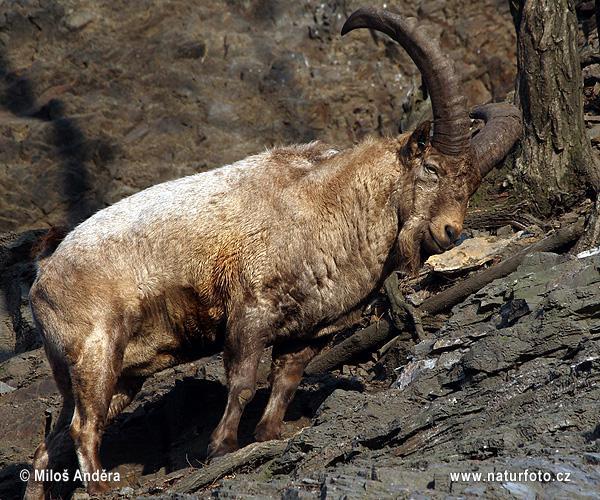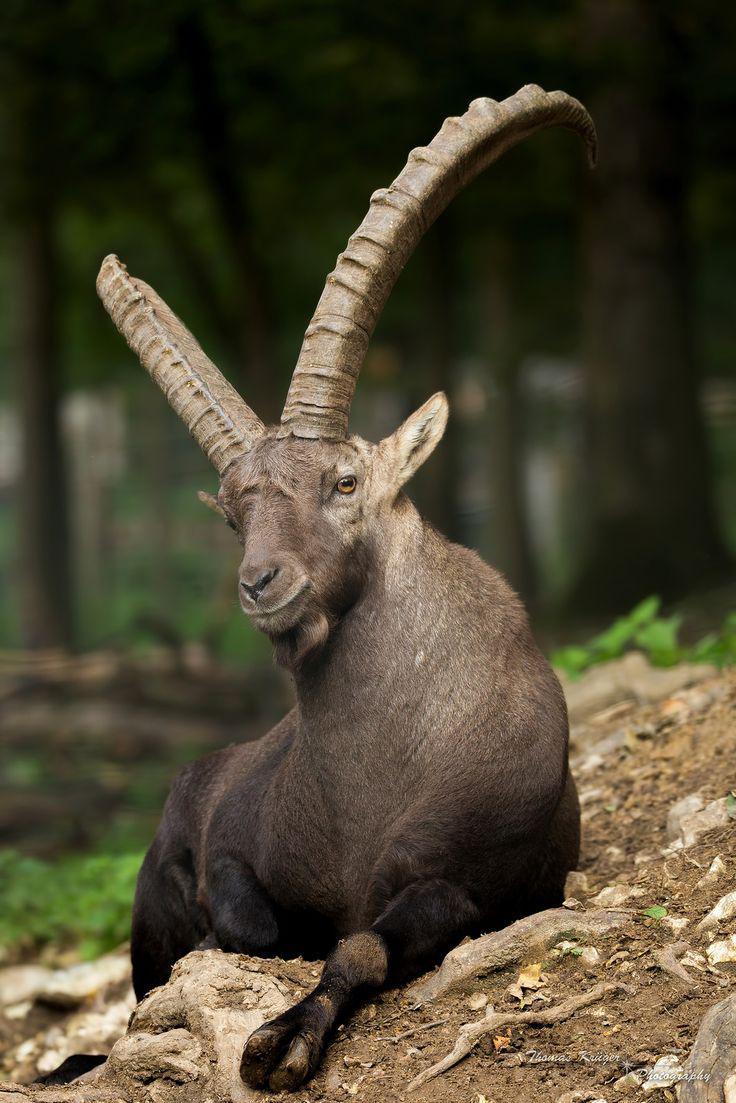The first image is the image on the left, the second image is the image on the right. Evaluate the accuracy of this statement regarding the images: "One of the goats is on the ground, resting.". Is it true? Answer yes or no. Yes. 